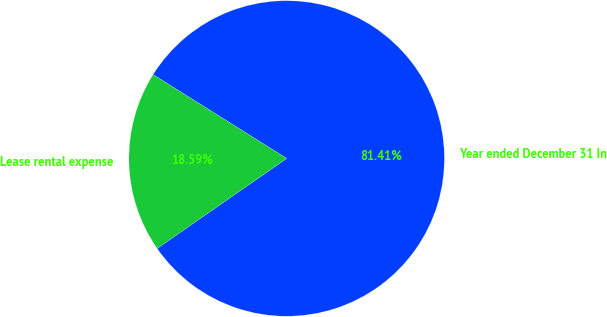Convert chart to OTSL. <chart><loc_0><loc_0><loc_500><loc_500><pie_chart><fcel>Year ended December 31 In<fcel>Lease rental expense<nl><fcel>81.41%<fcel>18.59%<nl></chart> 